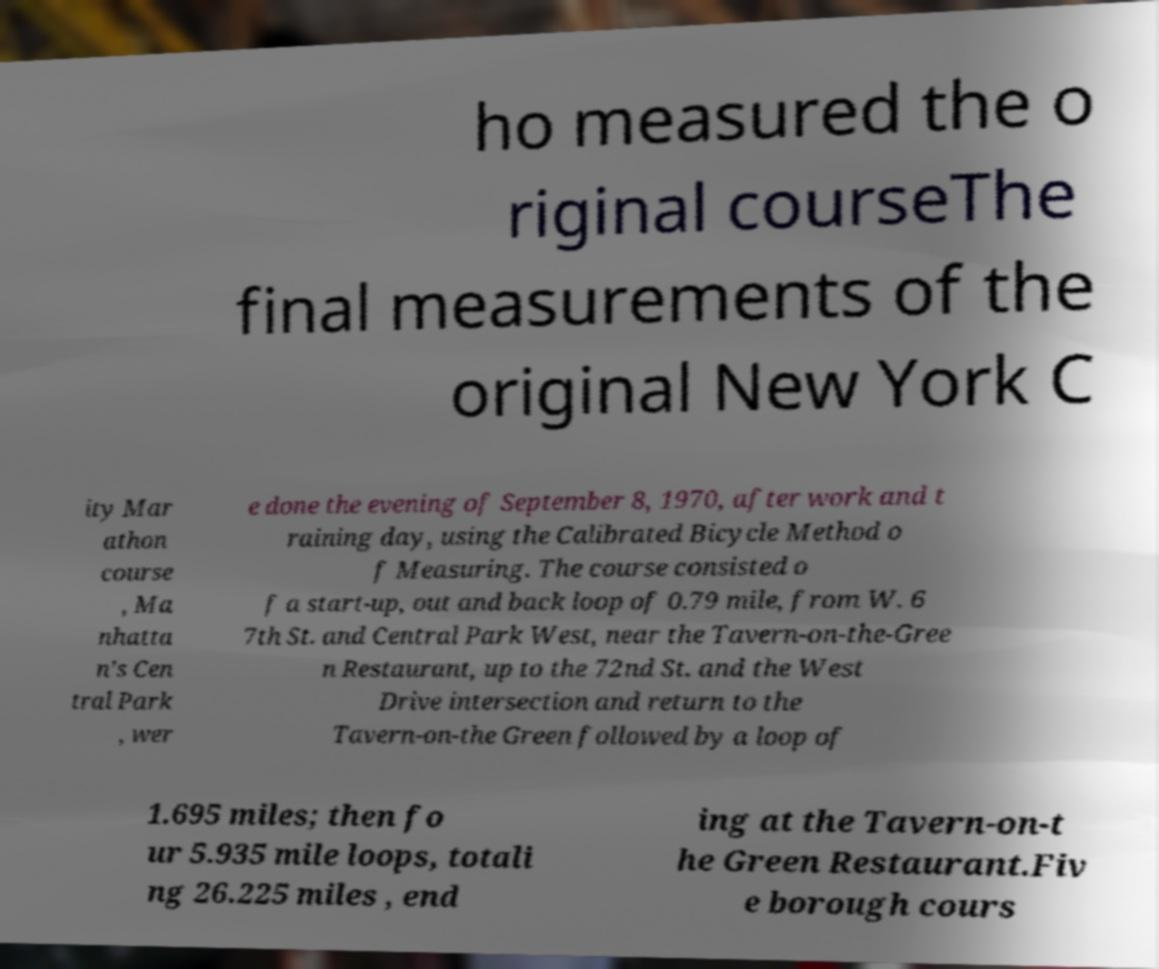Could you extract and type out the text from this image? ho measured the o riginal courseThe final measurements of the original New York C ity Mar athon course , Ma nhatta n’s Cen tral Park , wer e done the evening of September 8, 1970, after work and t raining day, using the Calibrated Bicycle Method o f Measuring. The course consisted o f a start-up, out and back loop of 0.79 mile, from W. 6 7th St. and Central Park West, near the Tavern-on-the-Gree n Restaurant, up to the 72nd St. and the West Drive intersection and return to the Tavern-on-the Green followed by a loop of 1.695 miles; then fo ur 5.935 mile loops, totali ng 26.225 miles , end ing at the Tavern-on-t he Green Restaurant.Fiv e borough cours 